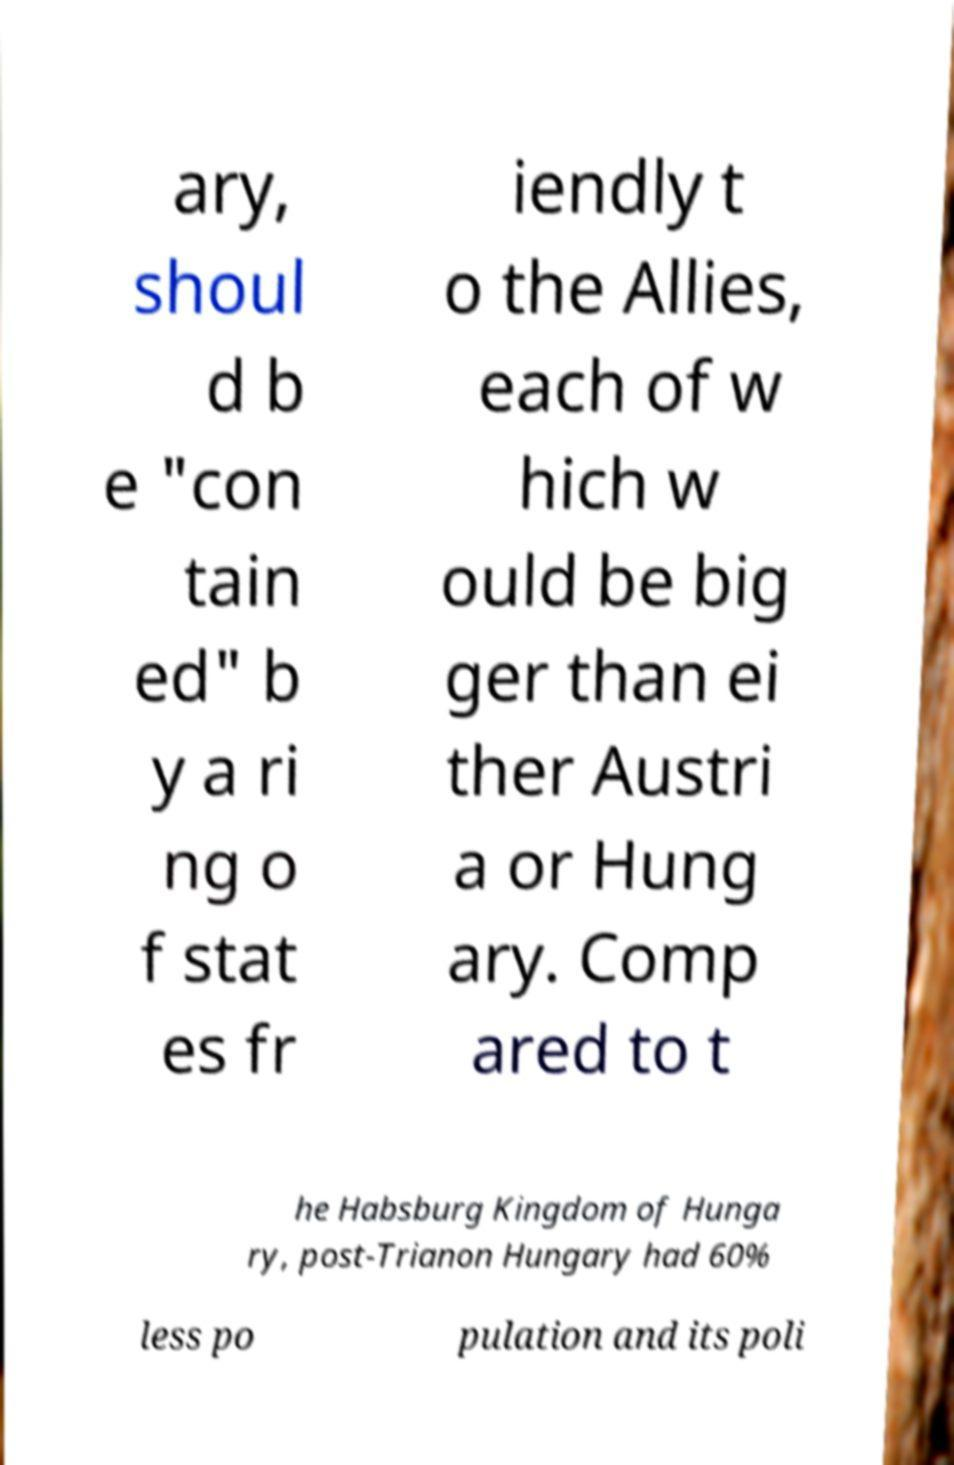What messages or text are displayed in this image? I need them in a readable, typed format. ary, shoul d b e "con tain ed" b y a ri ng o f stat es fr iendly t o the Allies, each of w hich w ould be big ger than ei ther Austri a or Hung ary. Comp ared to t he Habsburg Kingdom of Hunga ry, post-Trianon Hungary had 60% less po pulation and its poli 